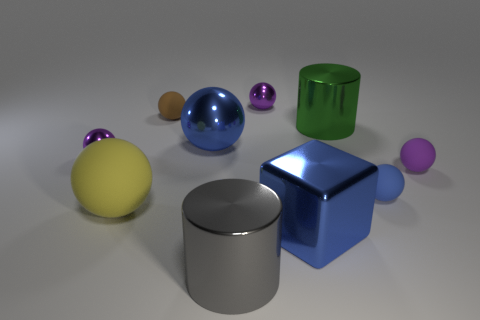Subtract all purple spheres. How many spheres are left? 4 Subtract all purple balls. How many balls are left? 4 Subtract 2 balls. How many balls are left? 5 Add 3 yellow rubber balls. How many yellow rubber balls exist? 4 Subtract 2 blue spheres. How many objects are left? 8 Subtract all blocks. How many objects are left? 9 Subtract all purple spheres. Subtract all green cubes. How many spheres are left? 4 Subtract all green cubes. How many green cylinders are left? 1 Subtract all yellow spheres. Subtract all tiny purple matte balls. How many objects are left? 8 Add 9 big metal blocks. How many big metal blocks are left? 10 